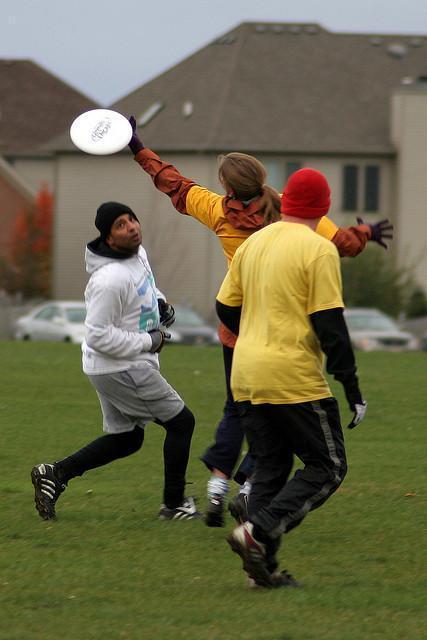How many  people are playing?
Give a very brief answer. 3. How many people are visible?
Give a very brief answer. 3. How many cars can you see?
Give a very brief answer. 2. 